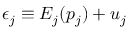Convert formula to latex. <formula><loc_0><loc_0><loc_500><loc_500>\epsilon _ { j } \equiv E _ { j } ( p _ { j } ) + u _ { j }</formula> 